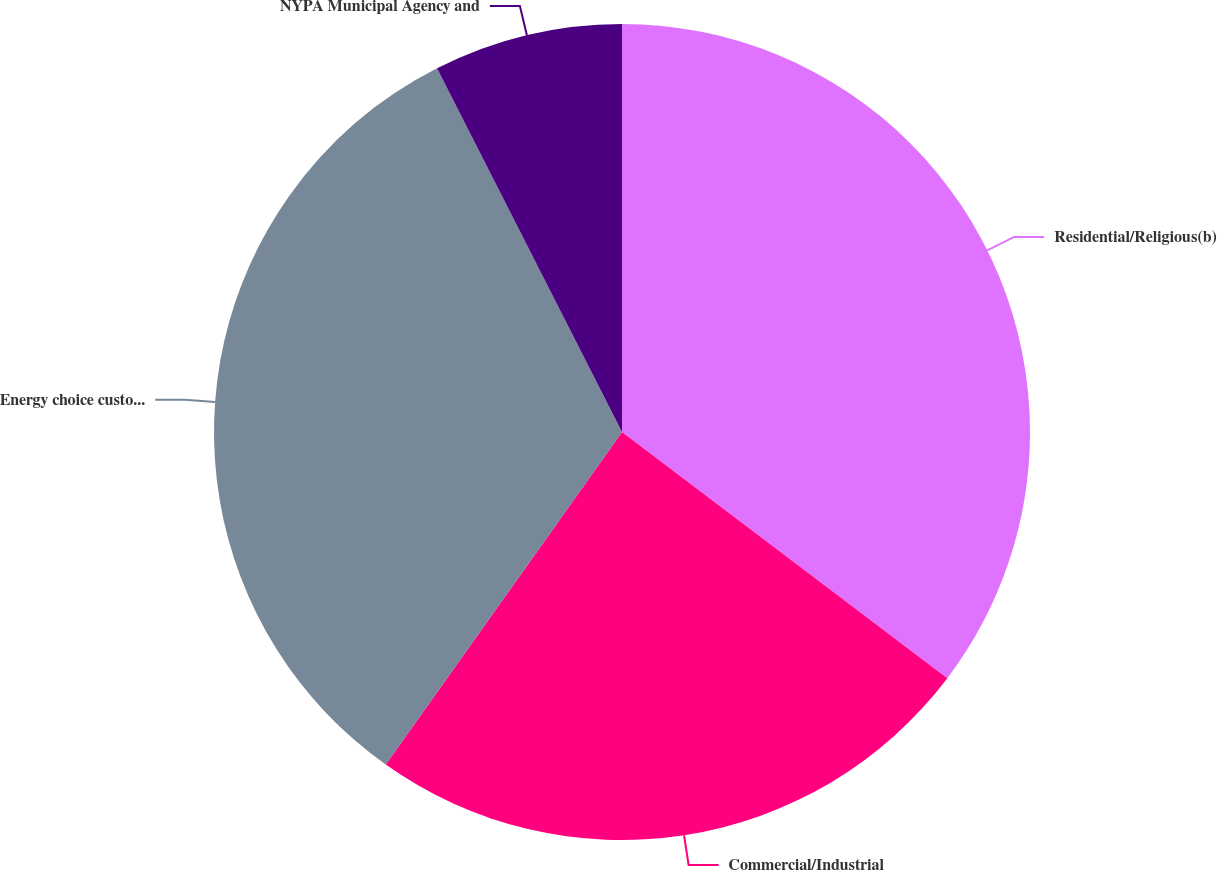Convert chart. <chart><loc_0><loc_0><loc_500><loc_500><pie_chart><fcel>Residential/Religious(b)<fcel>Commercial/Industrial<fcel>Energy choice customers<fcel>NYPA Municipal Agency and<nl><fcel>35.31%<fcel>24.52%<fcel>32.68%<fcel>7.49%<nl></chart> 